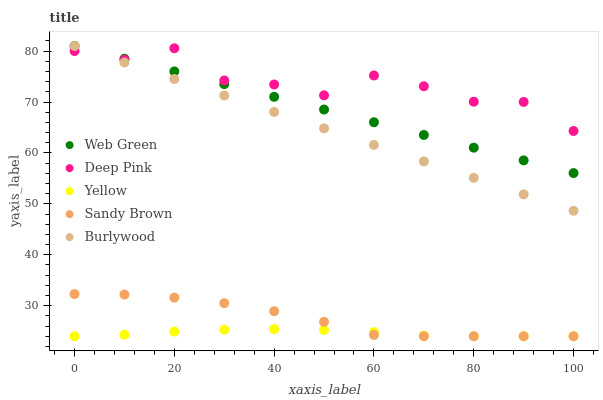Does Yellow have the minimum area under the curve?
Answer yes or no. Yes. Does Deep Pink have the maximum area under the curve?
Answer yes or no. Yes. Does Sandy Brown have the minimum area under the curve?
Answer yes or no. No. Does Sandy Brown have the maximum area under the curve?
Answer yes or no. No. Is Burlywood the smoothest?
Answer yes or no. Yes. Is Deep Pink the roughest?
Answer yes or no. Yes. Is Sandy Brown the smoothest?
Answer yes or no. No. Is Sandy Brown the roughest?
Answer yes or no. No. Does Sandy Brown have the lowest value?
Answer yes or no. Yes. Does Deep Pink have the lowest value?
Answer yes or no. No. Does Web Green have the highest value?
Answer yes or no. Yes. Does Deep Pink have the highest value?
Answer yes or no. No. Is Yellow less than Burlywood?
Answer yes or no. Yes. Is Deep Pink greater than Sandy Brown?
Answer yes or no. Yes. Does Deep Pink intersect Web Green?
Answer yes or no. Yes. Is Deep Pink less than Web Green?
Answer yes or no. No. Is Deep Pink greater than Web Green?
Answer yes or no. No. Does Yellow intersect Burlywood?
Answer yes or no. No. 